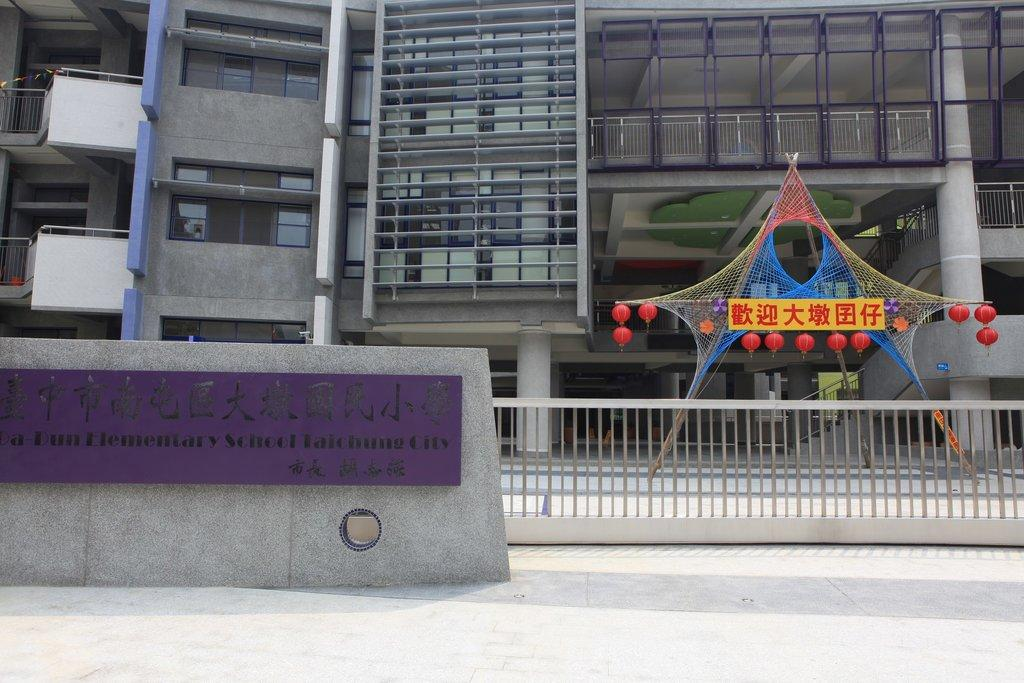What type of structure is present in the image? There is a building in the image. Can you describe any specific features of the building? There is a name board on the wall of the building. What is located near the building? There is a metal fence in the image. What can be seen in terms of illumination in the image? There are lights visible in the image. Can you tell me how many kitties are playing with oatmeal in the image? There are no kitties or oatmeal present in the image. 